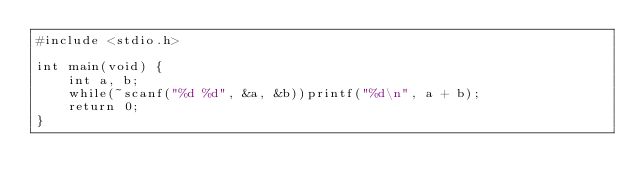<code> <loc_0><loc_0><loc_500><loc_500><_C_>#include <stdio.h>

int main(void) {
    int a, b;
    while(~scanf("%d %d", &a, &b))printf("%d\n", a + b);
    return 0;
}</code> 